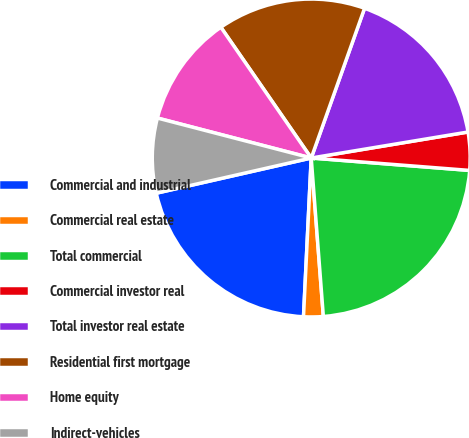<chart> <loc_0><loc_0><loc_500><loc_500><pie_chart><fcel>Commercial and industrial<fcel>Commercial real estate<fcel>Total commercial<fcel>Commercial investor real<fcel>Total investor real estate<fcel>Residential first mortgage<fcel>Home equity<fcel>Indirect-vehicles<nl><fcel>20.67%<fcel>1.99%<fcel>22.54%<fcel>3.86%<fcel>16.94%<fcel>15.07%<fcel>11.33%<fcel>7.6%<nl></chart> 